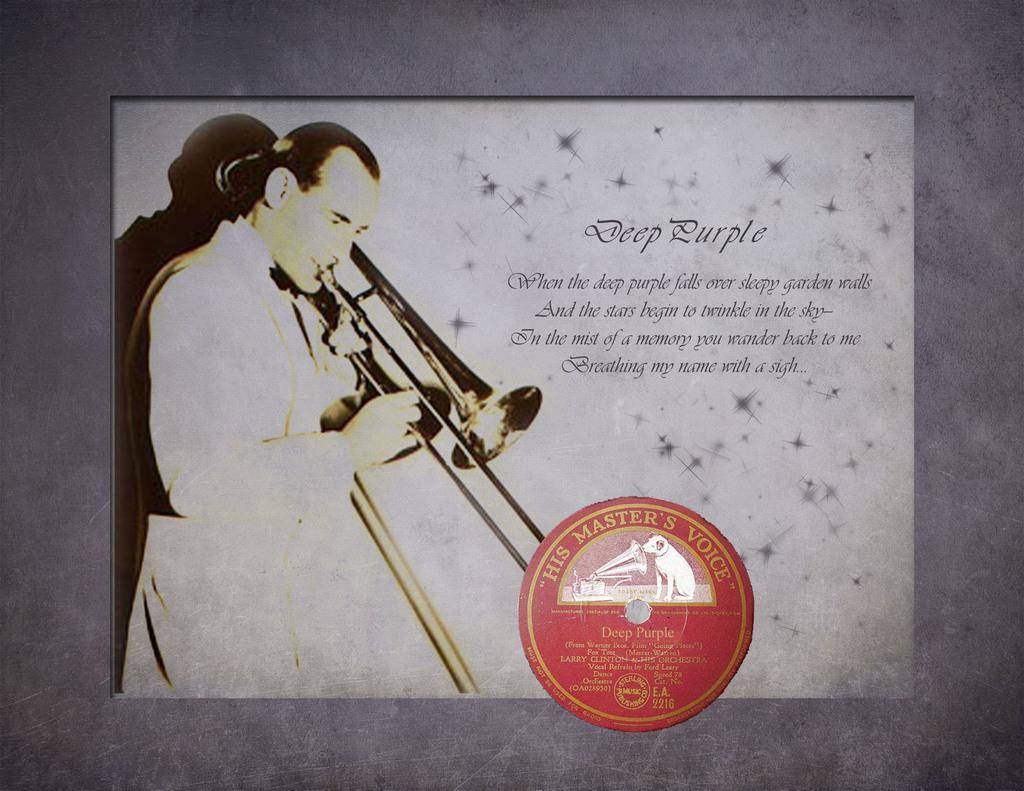Could you give a brief overview of what you see in this image? In this image we can see a poster with some text and images on it and in the background it looks like the wall. 